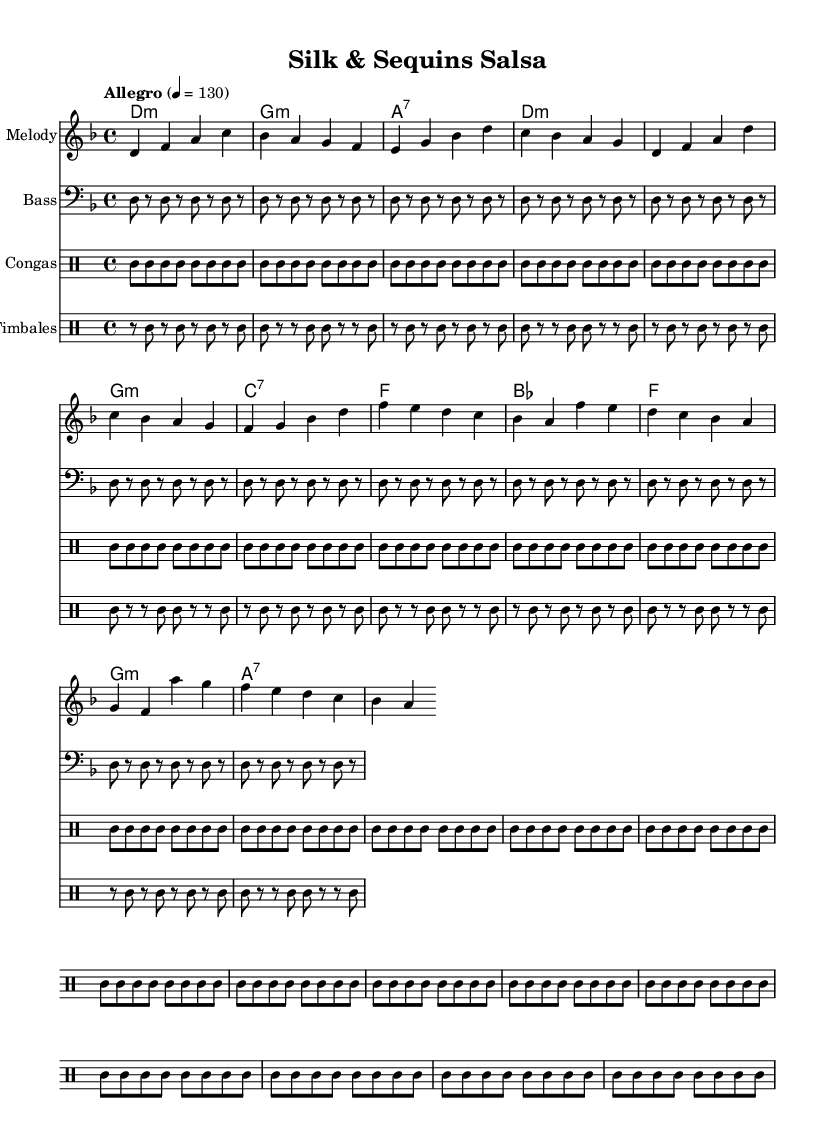What is the key signature of this music? The key signature is D minor, which has one flat (B flat). This can be determined by examining the key signature indicated at the beginning of the piece.
Answer: D minor What is the time signature of this music? The time signature is 4/4, which indicates that there are four beats in a measure and a quarter note receives one beat. This is shown near the beginning of the score.
Answer: 4/4 What is the tempo marking of this piece? The tempo marking is "Allegro," which indicates a lively and fast pace. In the score, it is clearly labeled at the beginning with the metronome marking of 130 beats per minute.
Answer: Allegro How many measures are in the chorus section? The chorus section consists of 4 measures, identifiable by counting the groups of notes in that specific section of the score.
Answer: 4 What type of rhythmic instruments are used in this piece? The rhythmic instruments used are congas and timbales, as indicated by the dedicated drum staves within the score designating their parts clearly.
Answer: Congas and timbales What is the harmonic progression used in the chorus? The harmonic progression in the chorus is B flat, F, G minor, and A7. This can be analyzed by looking at the chords notated underneath the melody during the chorus section.
Answer: B flat, F, G minor, A7 